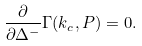Convert formula to latex. <formula><loc_0><loc_0><loc_500><loc_500>\frac { \partial } { \partial \Delta ^ { - } } \Gamma ( k _ { c } , P ) = 0 .</formula> 